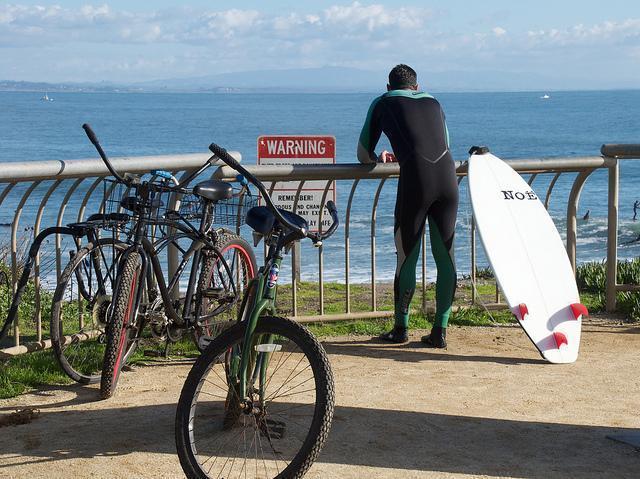What kind of surfboard it is?
Choose the right answer and clarify with the format: 'Answer: answer
Rationale: rationale.'
Options: Fish, spin, short board, fun. Answer: short board.
Rationale: The board is very short. 